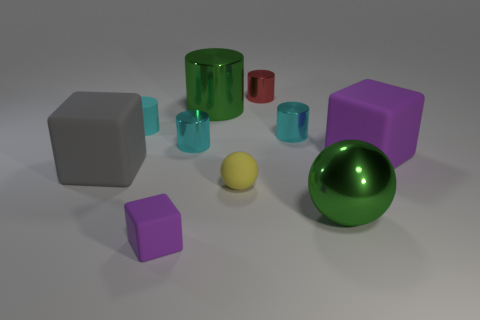Is the material of the large sphere the same as the green cylinder that is behind the yellow object?
Your answer should be compact. Yes. Is the number of cubes that are to the right of the tiny matte ball greater than the number of tiny red cylinders that are in front of the large purple rubber cube?
Provide a short and direct response. Yes. What is the color of the tiny matte sphere that is in front of the cyan metallic thing that is to the right of the tiny red metal thing?
Give a very brief answer. Yellow. How many cylinders are yellow shiny things or gray things?
Offer a very short reply. 0. How many matte blocks are both behind the gray object and on the left side of the red metallic cylinder?
Provide a short and direct response. 0. What color is the tiny metal cylinder left of the red cylinder?
Your answer should be very brief. Cyan. What size is the green sphere that is made of the same material as the large green cylinder?
Keep it short and to the point. Large. What number of rubber cylinders are in front of the big metallic thing that is in front of the green cylinder?
Ensure brevity in your answer.  0. What number of gray objects are in front of the tiny yellow rubber ball?
Offer a very short reply. 0. What color is the cylinder behind the large green thing to the left of the small metallic object on the right side of the red cylinder?
Your response must be concise. Red. 